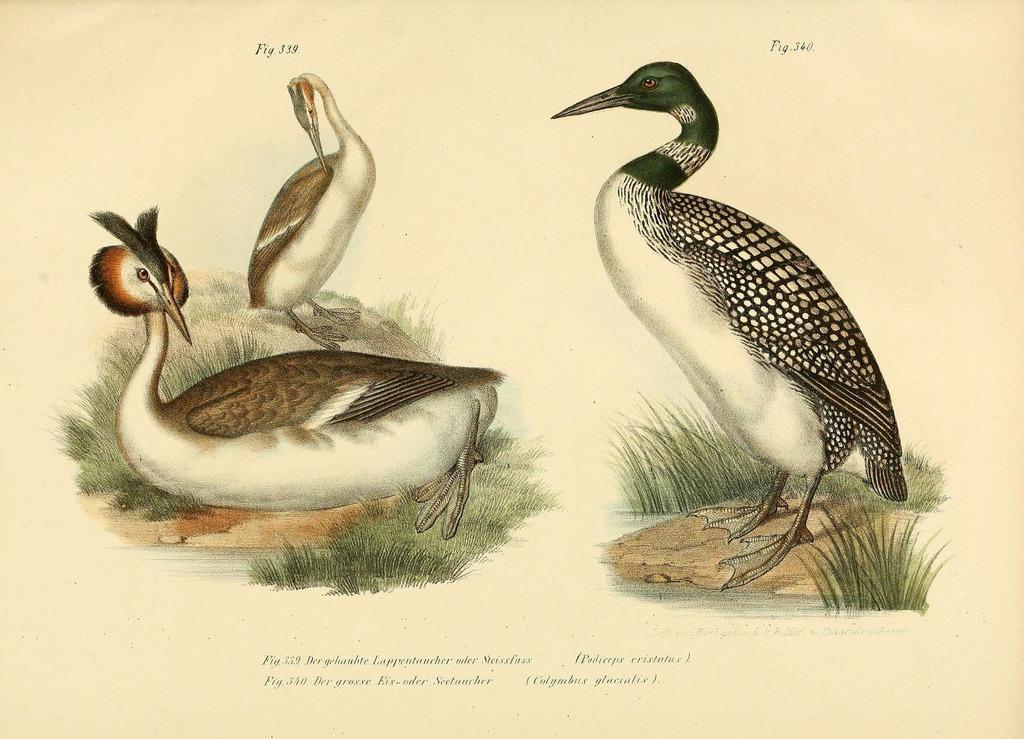Can you describe this image briefly? In this image we can see the poster with the painting of birds and grass on the ground and we can see some text on the poster. 